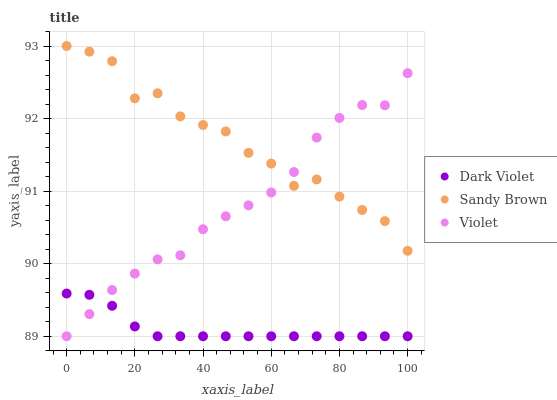Does Dark Violet have the minimum area under the curve?
Answer yes or no. Yes. Does Sandy Brown have the maximum area under the curve?
Answer yes or no. Yes. Does Violet have the minimum area under the curve?
Answer yes or no. No. Does Violet have the maximum area under the curve?
Answer yes or no. No. Is Dark Violet the smoothest?
Answer yes or no. Yes. Is Sandy Brown the roughest?
Answer yes or no. Yes. Is Violet the smoothest?
Answer yes or no. No. Is Violet the roughest?
Answer yes or no. No. Does Dark Violet have the lowest value?
Answer yes or no. Yes. Does Sandy Brown have the highest value?
Answer yes or no. Yes. Does Violet have the highest value?
Answer yes or no. No. Is Dark Violet less than Sandy Brown?
Answer yes or no. Yes. Is Sandy Brown greater than Dark Violet?
Answer yes or no. Yes. Does Dark Violet intersect Violet?
Answer yes or no. Yes. Is Dark Violet less than Violet?
Answer yes or no. No. Is Dark Violet greater than Violet?
Answer yes or no. No. Does Dark Violet intersect Sandy Brown?
Answer yes or no. No. 